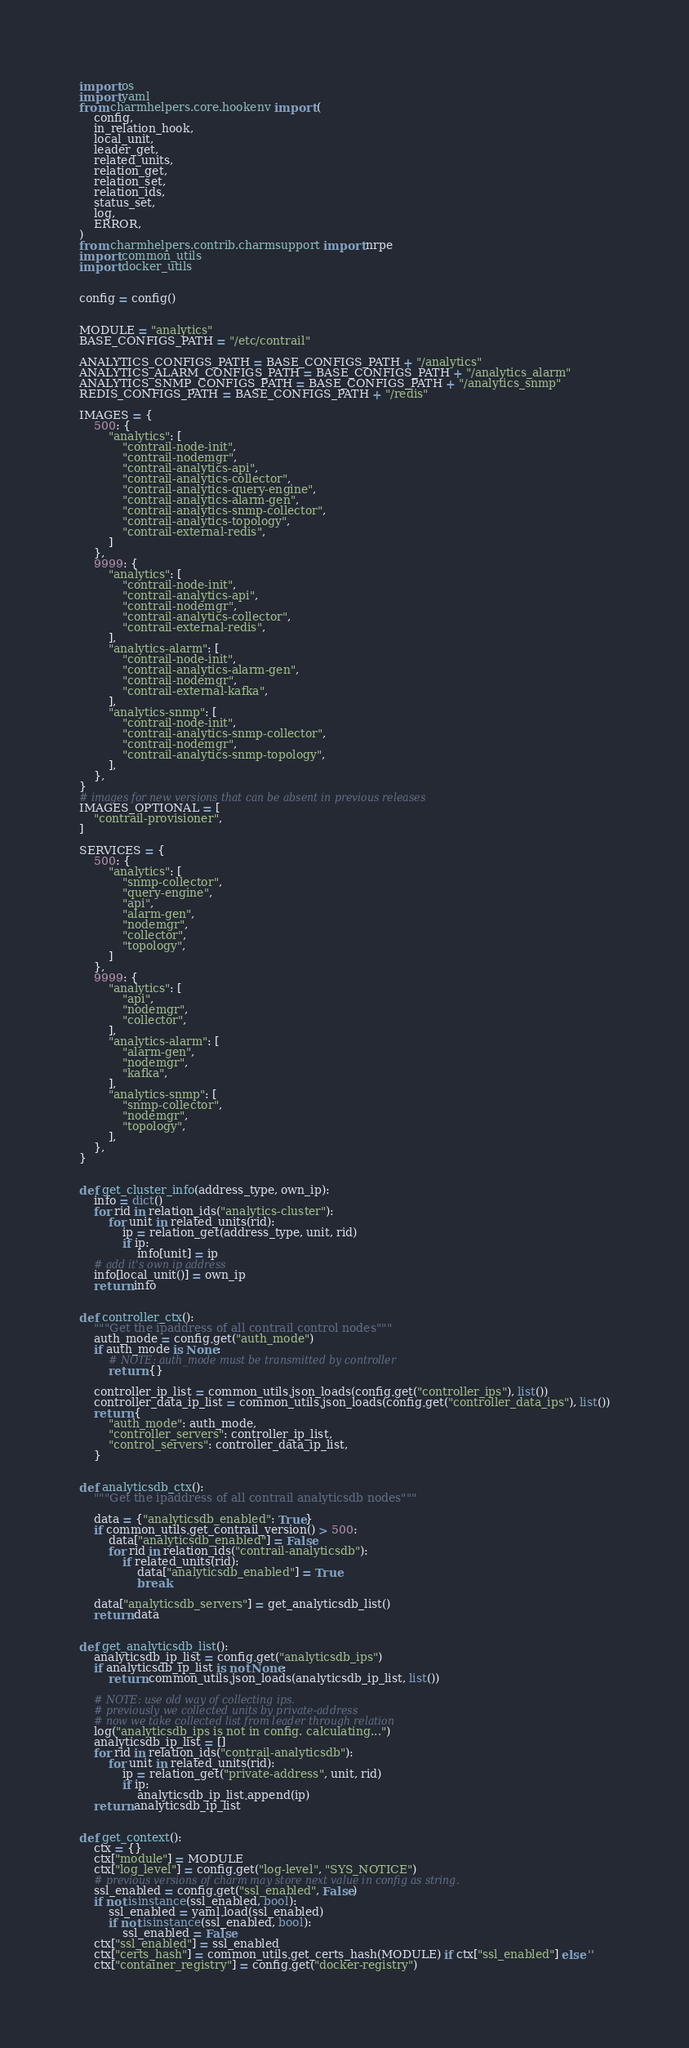<code> <loc_0><loc_0><loc_500><loc_500><_Python_>import os
import yaml
from charmhelpers.core.hookenv import (
    config,
    in_relation_hook,
    local_unit,
    leader_get,
    related_units,
    relation_get,
    relation_set,
    relation_ids,
    status_set,
    log,
    ERROR,
)
from charmhelpers.contrib.charmsupport import nrpe
import common_utils
import docker_utils


config = config()


MODULE = "analytics"
BASE_CONFIGS_PATH = "/etc/contrail"

ANALYTICS_CONFIGS_PATH = BASE_CONFIGS_PATH + "/analytics"
ANALYTICS_ALARM_CONFIGS_PATH = BASE_CONFIGS_PATH + "/analytics_alarm"
ANALYTICS_SNMP_CONFIGS_PATH = BASE_CONFIGS_PATH + "/analytics_snmp"
REDIS_CONFIGS_PATH = BASE_CONFIGS_PATH + "/redis"

IMAGES = {
    500: {
        "analytics": [
            "contrail-node-init",
            "contrail-nodemgr",
            "contrail-analytics-api",
            "contrail-analytics-collector",
            "contrail-analytics-query-engine",
            "contrail-analytics-alarm-gen",
            "contrail-analytics-snmp-collector",
            "contrail-analytics-topology",
            "contrail-external-redis",
        ]
    },
    9999: {
        "analytics": [
            "contrail-node-init",
            "contrail-analytics-api",
            "contrail-nodemgr",
            "contrail-analytics-collector",
            "contrail-external-redis",
        ],
        "analytics-alarm": [
            "contrail-node-init",
            "contrail-analytics-alarm-gen",
            "contrail-nodemgr",
            "contrail-external-kafka",
        ],
        "analytics-snmp": [
            "contrail-node-init",
            "contrail-analytics-snmp-collector",
            "contrail-nodemgr",
            "contrail-analytics-snmp-topology",
        ],
    },
}
# images for new versions that can be absent in previous releases
IMAGES_OPTIONAL = [
    "contrail-provisioner",
]

SERVICES = {
    500: {
        "analytics": [
            "snmp-collector",
            "query-engine",
            "api",
            "alarm-gen",
            "nodemgr",
            "collector",
            "topology",
        ]
    },
    9999: {
        "analytics": [
            "api",
            "nodemgr",
            "collector",
        ],
        "analytics-alarm": [
            "alarm-gen",
            "nodemgr",
            "kafka",
        ],
        "analytics-snmp": [
            "snmp-collector",
            "nodemgr",
            "topology",
        ],
    },
}


def get_cluster_info(address_type, own_ip):
    info = dict()
    for rid in relation_ids("analytics-cluster"):
        for unit in related_units(rid):
            ip = relation_get(address_type, unit, rid)
            if ip:
                info[unit] = ip
    # add it's own ip address
    info[local_unit()] = own_ip
    return info


def controller_ctx():
    """Get the ipaddress of all contrail control nodes"""
    auth_mode = config.get("auth_mode")
    if auth_mode is None:
        # NOTE: auth_mode must be transmitted by controller
        return {}

    controller_ip_list = common_utils.json_loads(config.get("controller_ips"), list())
    controller_data_ip_list = common_utils.json_loads(config.get("controller_data_ips"), list())
    return {
        "auth_mode": auth_mode,
        "controller_servers": controller_ip_list,
        "control_servers": controller_data_ip_list,
    }


def analyticsdb_ctx():
    """Get the ipaddress of all contrail analyticsdb nodes"""

    data = {"analyticsdb_enabled": True}
    if common_utils.get_contrail_version() > 500:
        data["analyticsdb_enabled"] = False
        for rid in relation_ids("contrail-analyticsdb"):
            if related_units(rid):
                data["analyticsdb_enabled"] = True
                break

    data["analyticsdb_servers"] = get_analyticsdb_list()
    return data


def get_analyticsdb_list():
    analyticsdb_ip_list = config.get("analyticsdb_ips")
    if analyticsdb_ip_list is not None:
        return common_utils.json_loads(analyticsdb_ip_list, list())

    # NOTE: use old way of collecting ips.
    # previously we collected units by private-address
    # now we take collected list from leader through relation
    log("analyticsdb_ips is not in config. calculating...")
    analyticsdb_ip_list = []
    for rid in relation_ids("contrail-analyticsdb"):
        for unit in related_units(rid):
            ip = relation_get("private-address", unit, rid)
            if ip:
                analyticsdb_ip_list.append(ip)
    return analyticsdb_ip_list


def get_context():
    ctx = {}
    ctx["module"] = MODULE
    ctx["log_level"] = config.get("log-level", "SYS_NOTICE")
    # previous versions of charm may store next value in config as string.
    ssl_enabled = config.get("ssl_enabled", False)
    if not isinstance(ssl_enabled, bool):
        ssl_enabled = yaml.load(ssl_enabled)
        if not isinstance(ssl_enabled, bool):
            ssl_enabled = False
    ctx["ssl_enabled"] = ssl_enabled
    ctx["certs_hash"] = common_utils.get_certs_hash(MODULE) if ctx["ssl_enabled"] else ''
    ctx["container_registry"] = config.get("docker-registry")</code> 